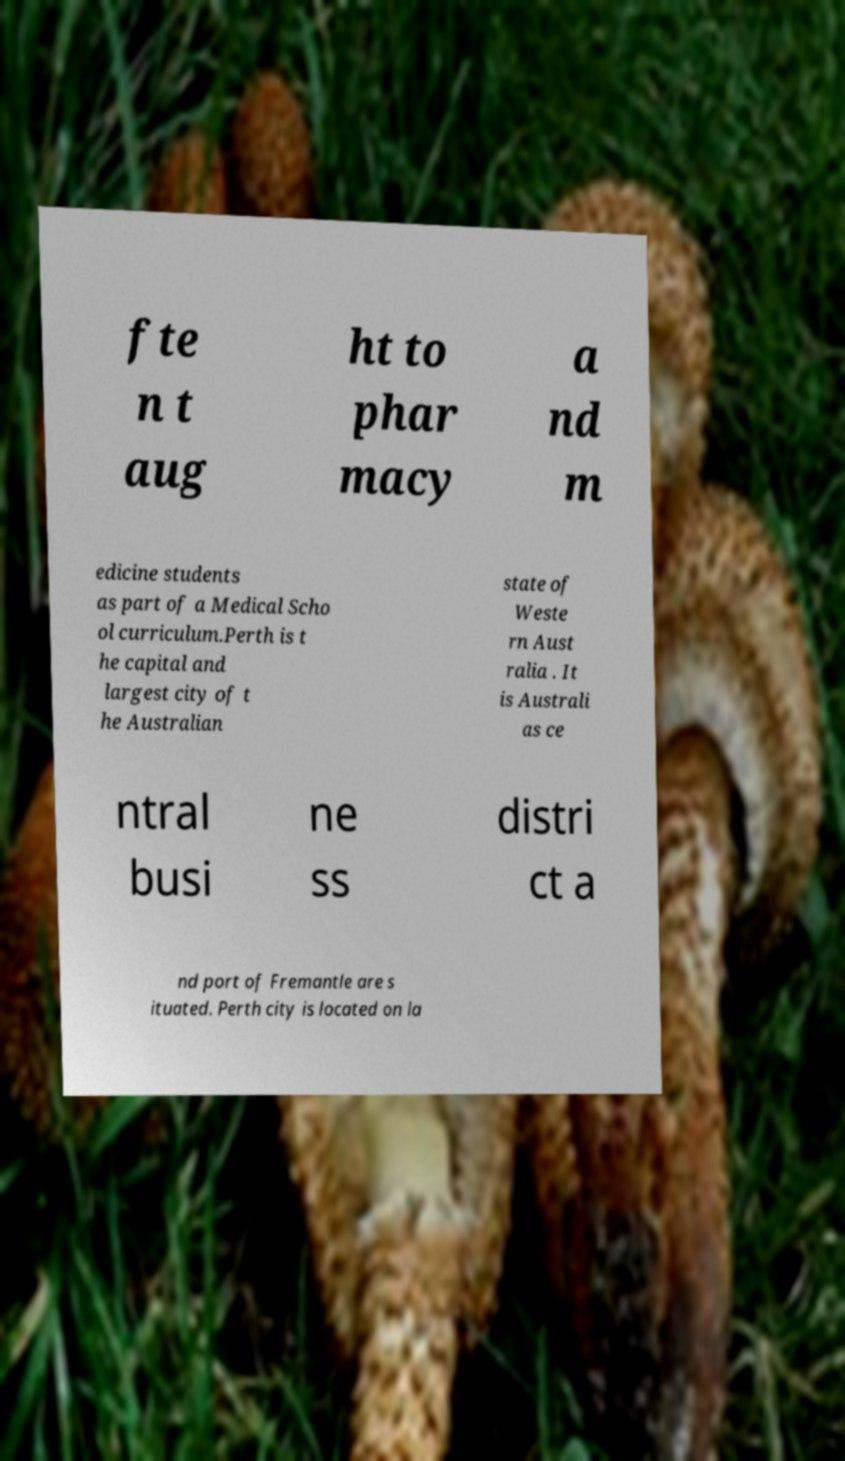For documentation purposes, I need the text within this image transcribed. Could you provide that? fte n t aug ht to phar macy a nd m edicine students as part of a Medical Scho ol curriculum.Perth is t he capital and largest city of t he Australian state of Weste rn Aust ralia . It is Australi as ce ntral busi ne ss distri ct a nd port of Fremantle are s ituated. Perth city is located on la 